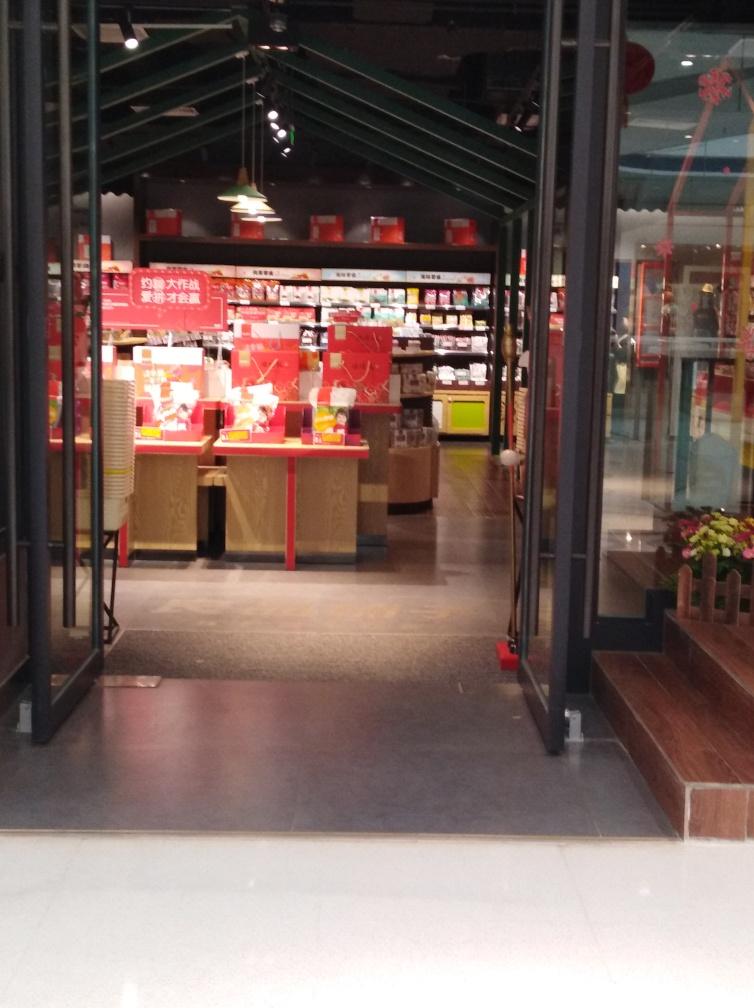Is the composition of the image properly aligned? The composition of the image is generally aligned within acceptable limits, although it appears slightly off-center. The perspective provided seems to be looking into a store which has notable symmetry in its structural design. The positioning of the camera is mostly central, but there is a slight shift to the right, possibly due to the angle of the doorway. Despite this minor deviation, the overall composition does not detract significantly from the image's viewing experience. 